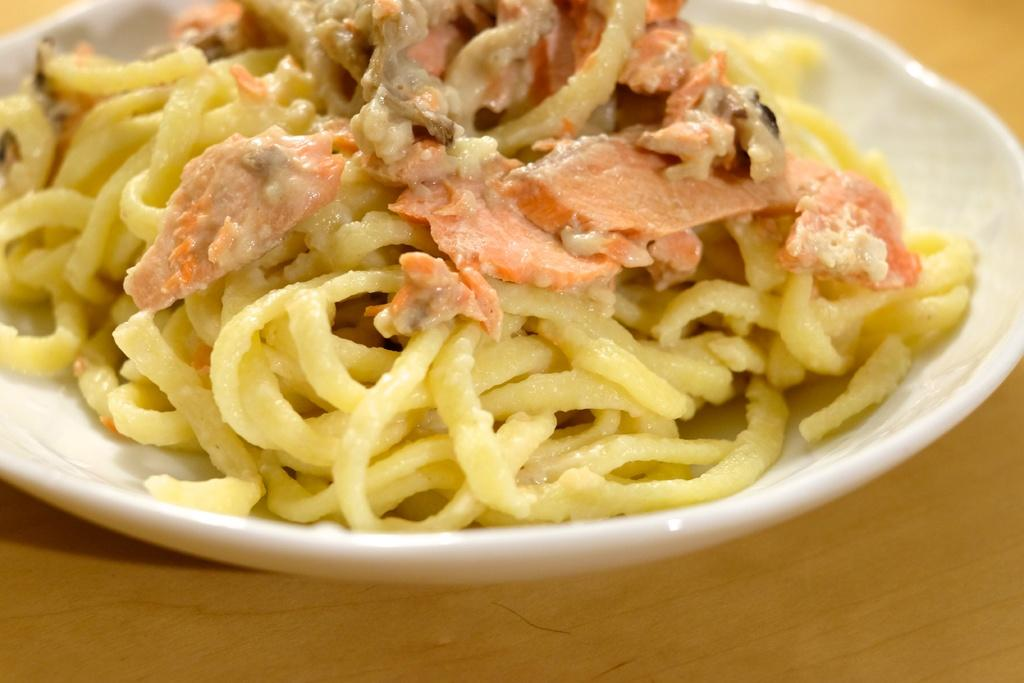What is on the plate that is visible in the image? There is food on a plate in the image. Where is the plate located in the image? The plate is placed on a table in the image. What type of skate is being used to transport the food in the image? There is no skate present in the image, and the food is not being transported. 